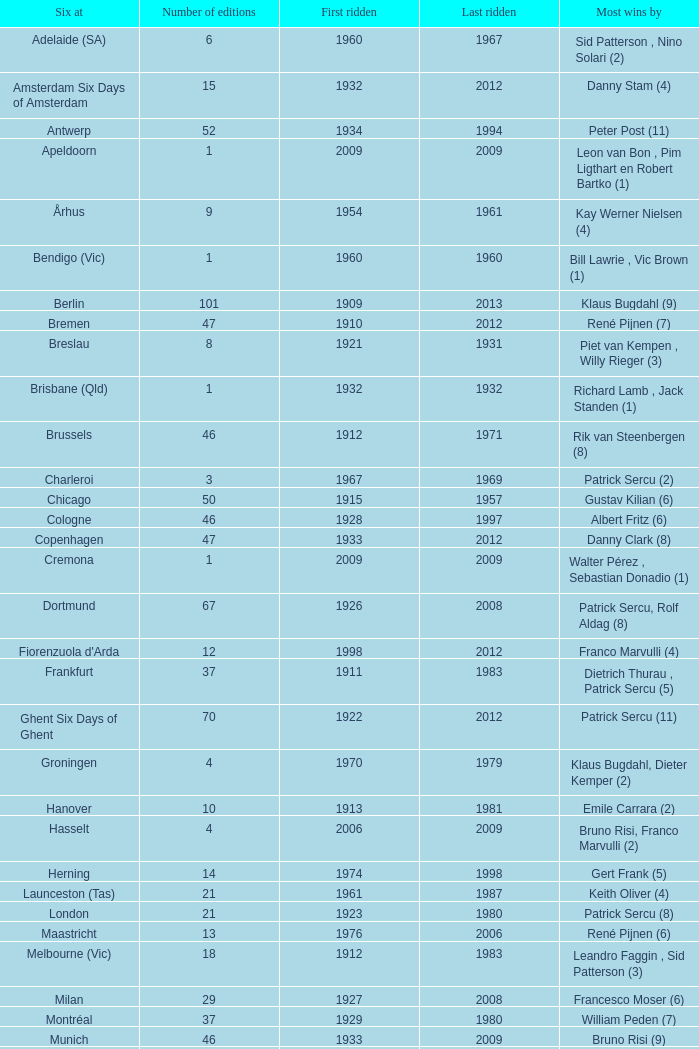How many editions have a most wins value of Franco Marvulli (4)? 1.0. 